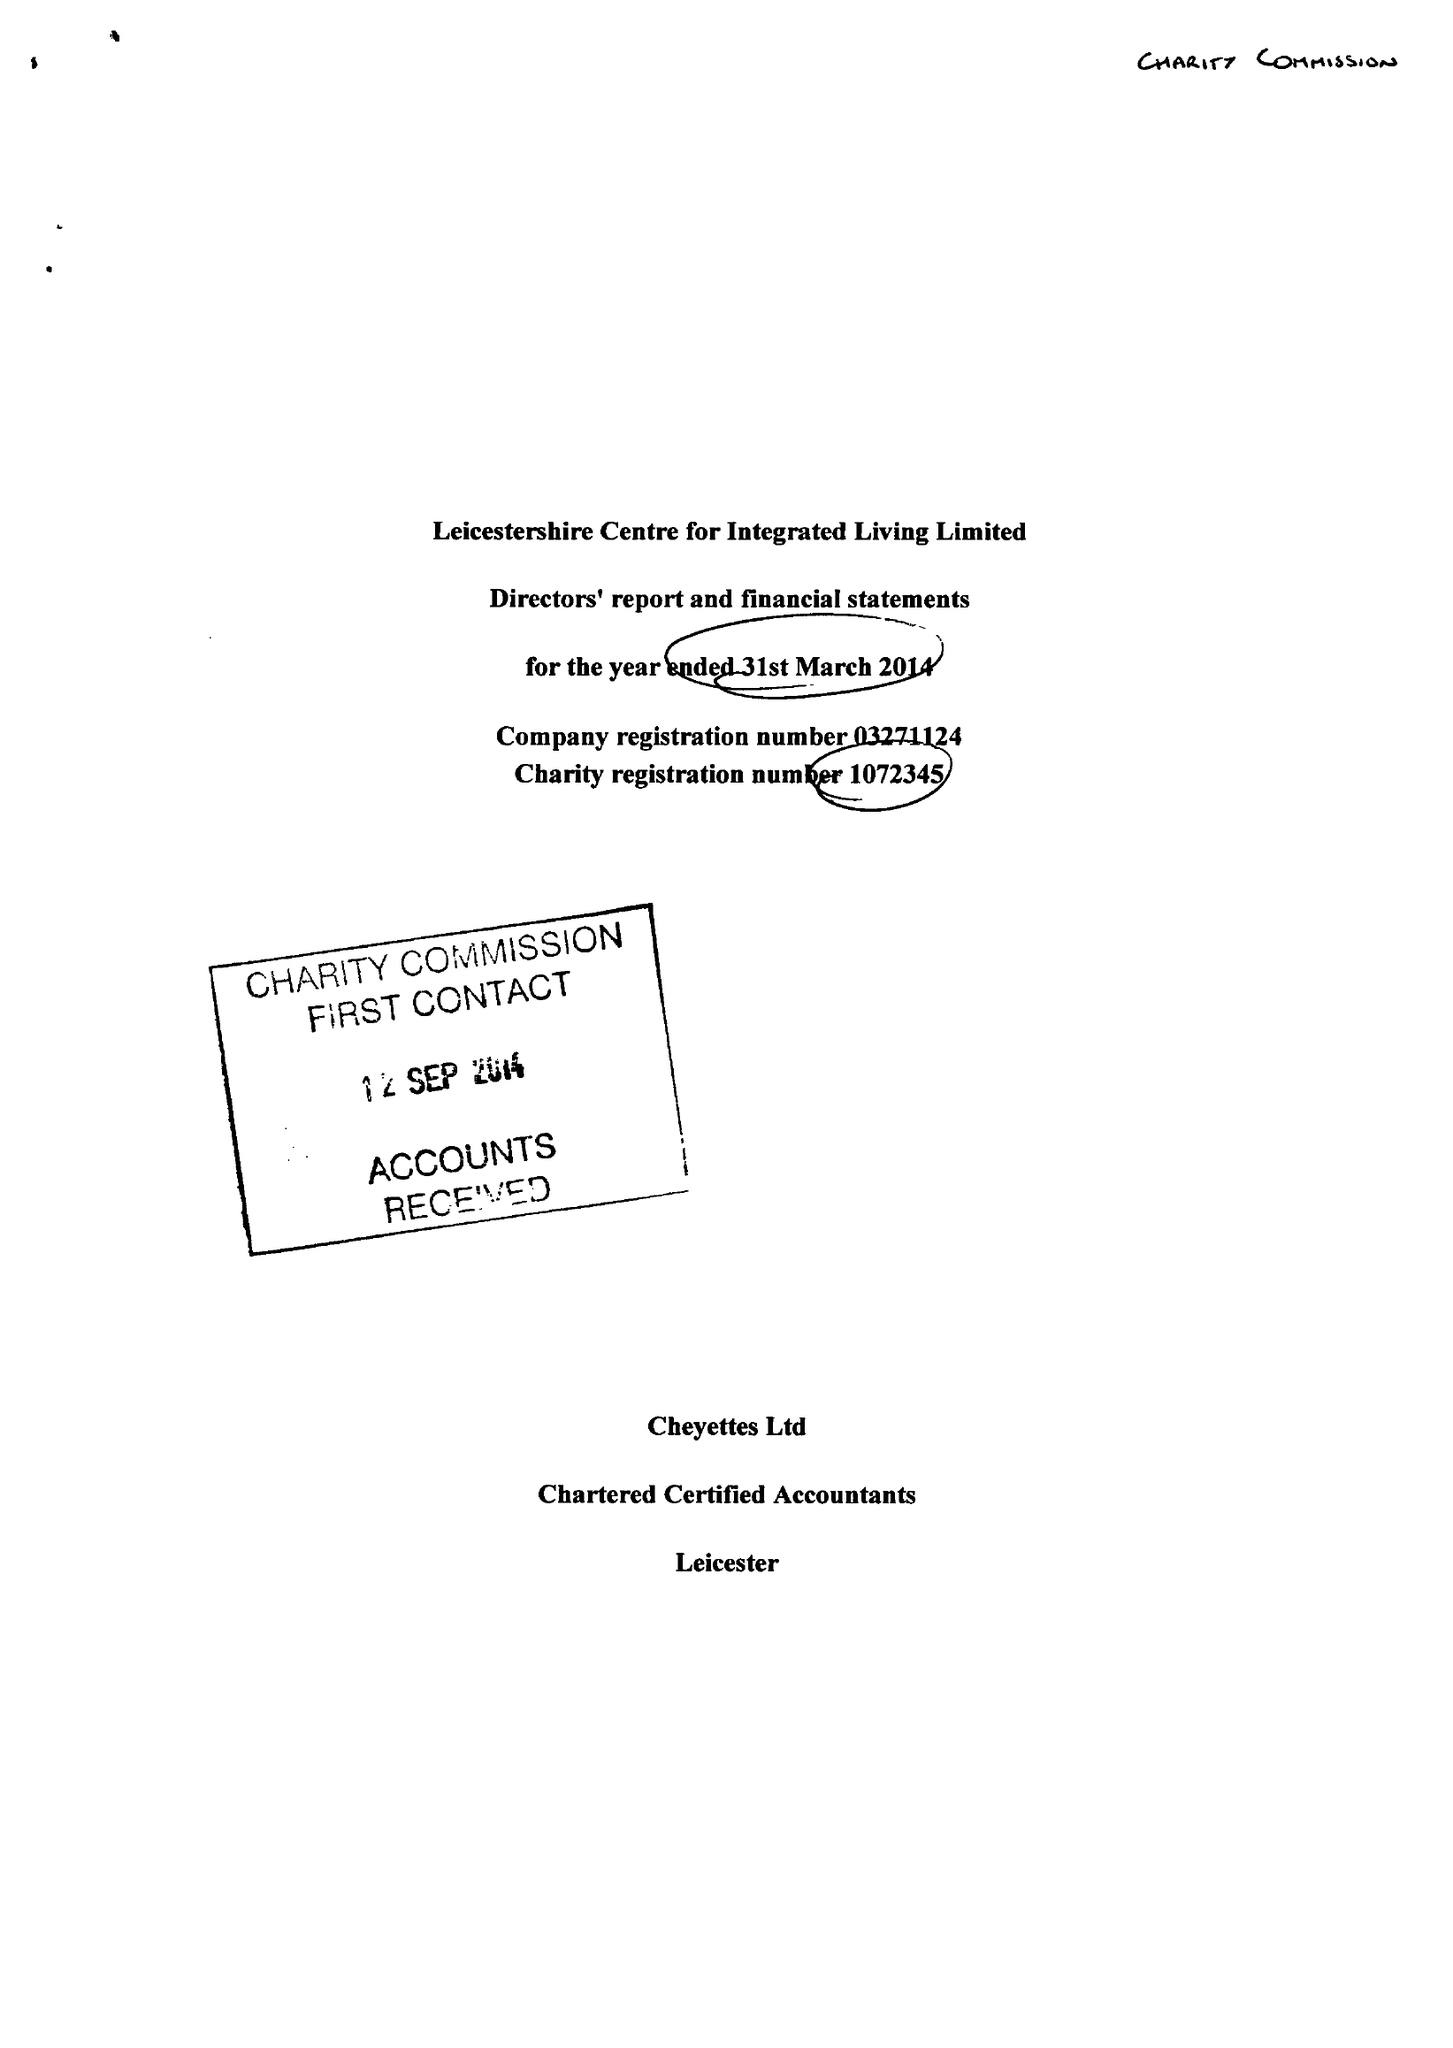What is the value for the spending_annually_in_british_pounds?
Answer the question using a single word or phrase. 216634.00 